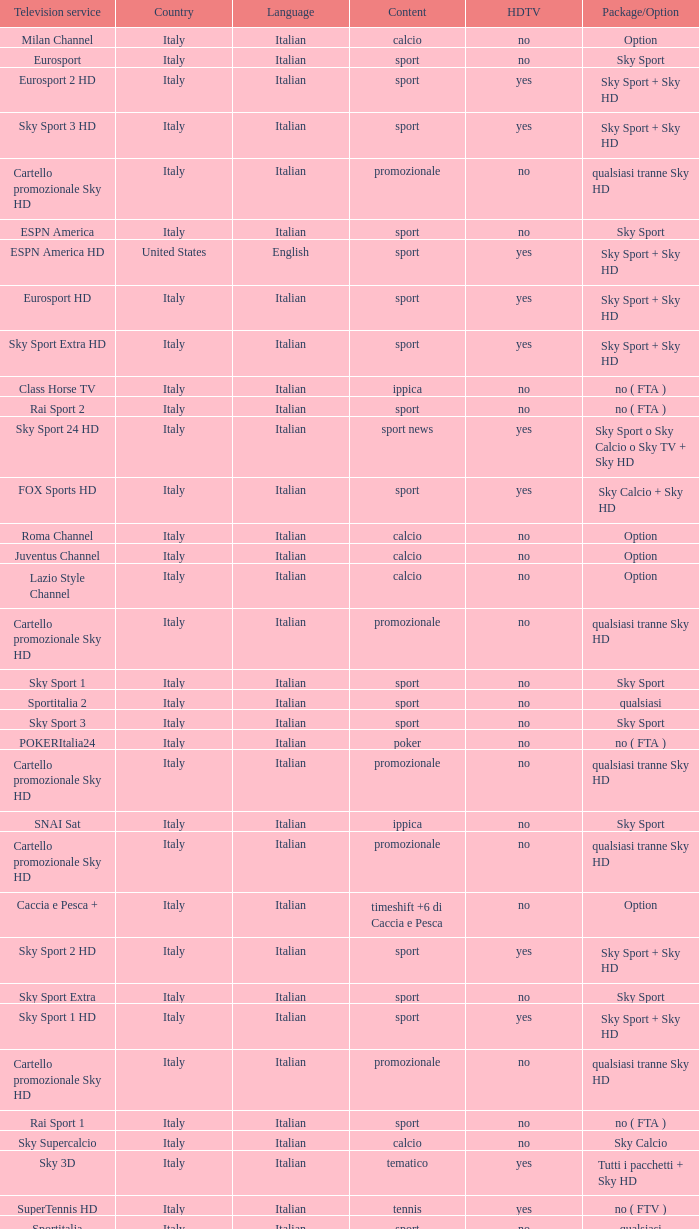What is Package/Option, when Content is Tennis? No ( ftv ). 